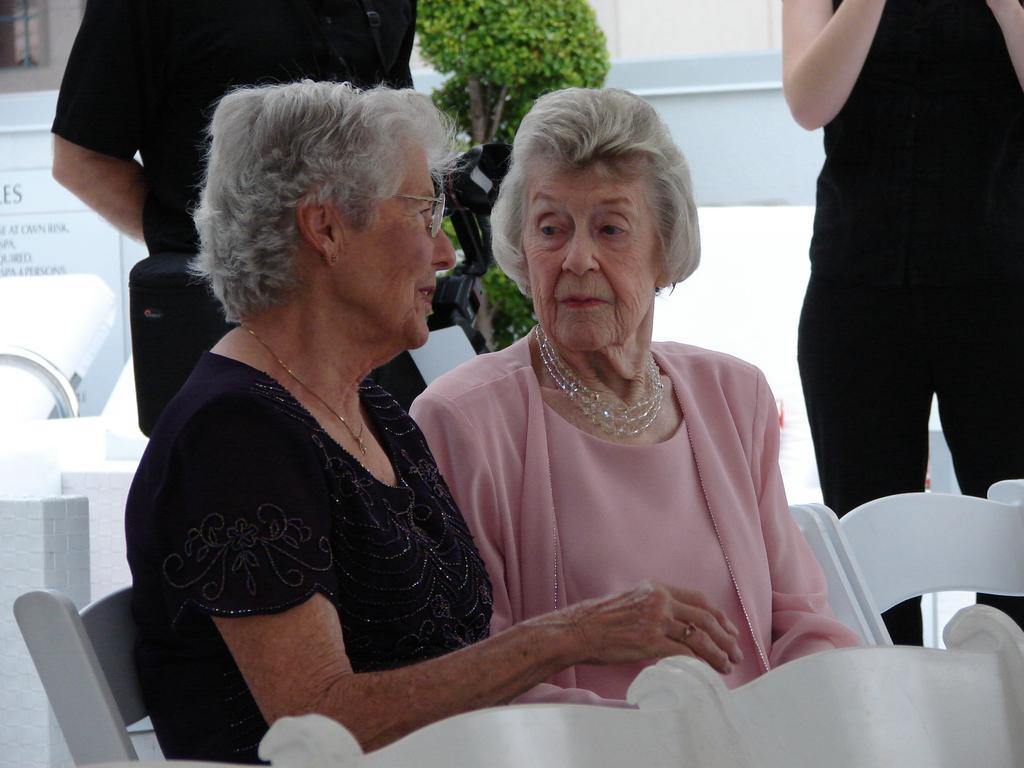Could you give a brief overview of what you see in this image? In this image we can see two ladies are sitting on the white chair. One lady is wearing black color dress and the other one is wearing pink color. Behind them one woman is standing, she is wearing black color dress and the man is standing, he is also wearing black color. Bottom of the image white chairs are there. Background one tree is present. 